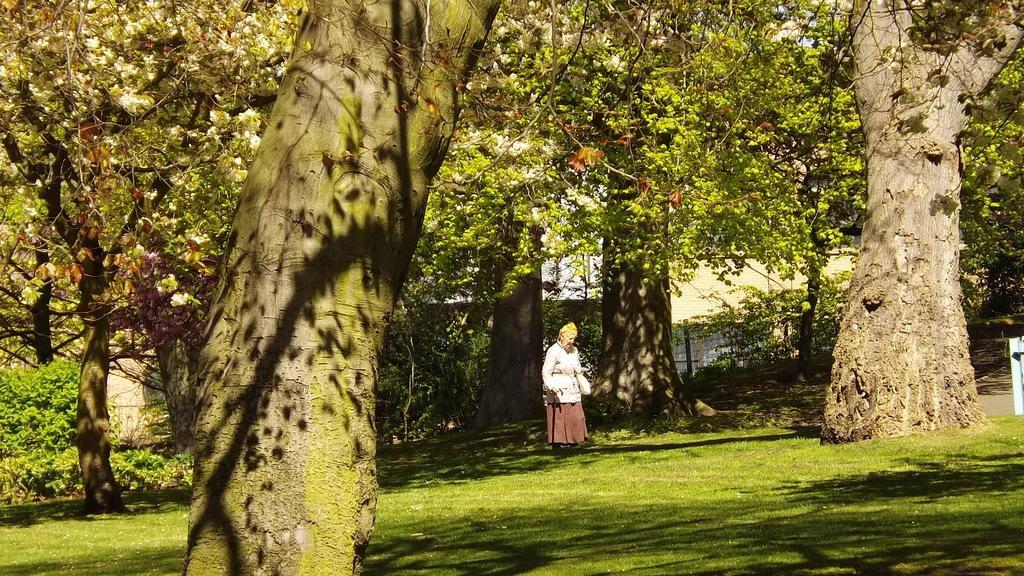Please provide a concise description of this image. In this picture we can see trees, plants and grass. Here we can see a woman standing. 